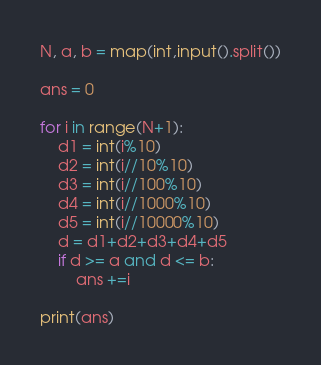<code> <loc_0><loc_0><loc_500><loc_500><_Python_>N, a, b = map(int,input().split())

ans = 0

for i in range(N+1):
    d1 = int(i%10)
    d2 = int(i//10%10)
    d3 = int(i//100%10)
    d4 = int(i//1000%10)
    d5 = int(i//10000%10)
    d = d1+d2+d3+d4+d5
    if d >= a and d <= b:
        ans +=i

print(ans)</code> 